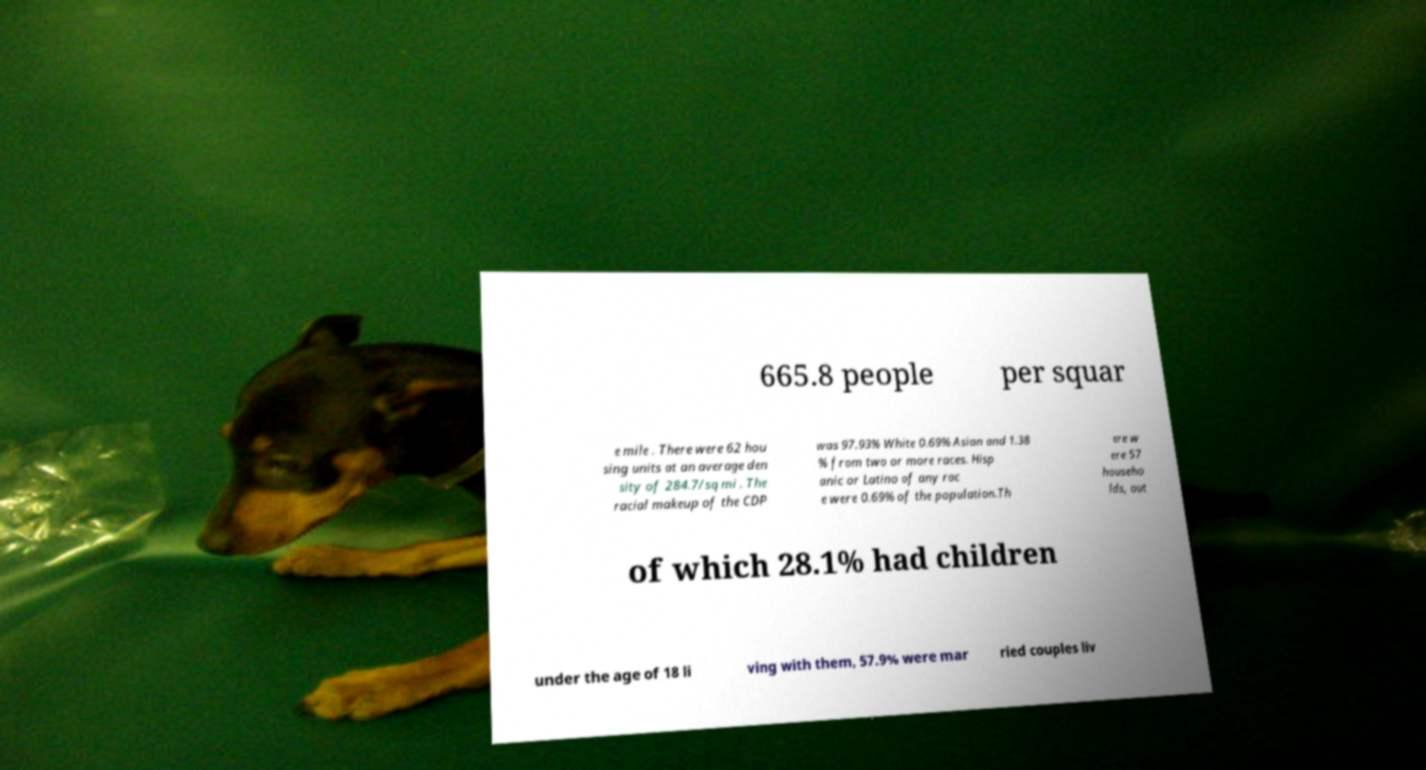For documentation purposes, I need the text within this image transcribed. Could you provide that? 665.8 people per squar e mile . There were 62 hou sing units at an average den sity of 284.7/sq mi . The racial makeup of the CDP was 97.93% White 0.69% Asian and 1.38 % from two or more races. Hisp anic or Latino of any rac e were 0.69% of the population.Th ere w ere 57 househo lds, out of which 28.1% had children under the age of 18 li ving with them, 57.9% were mar ried couples liv 